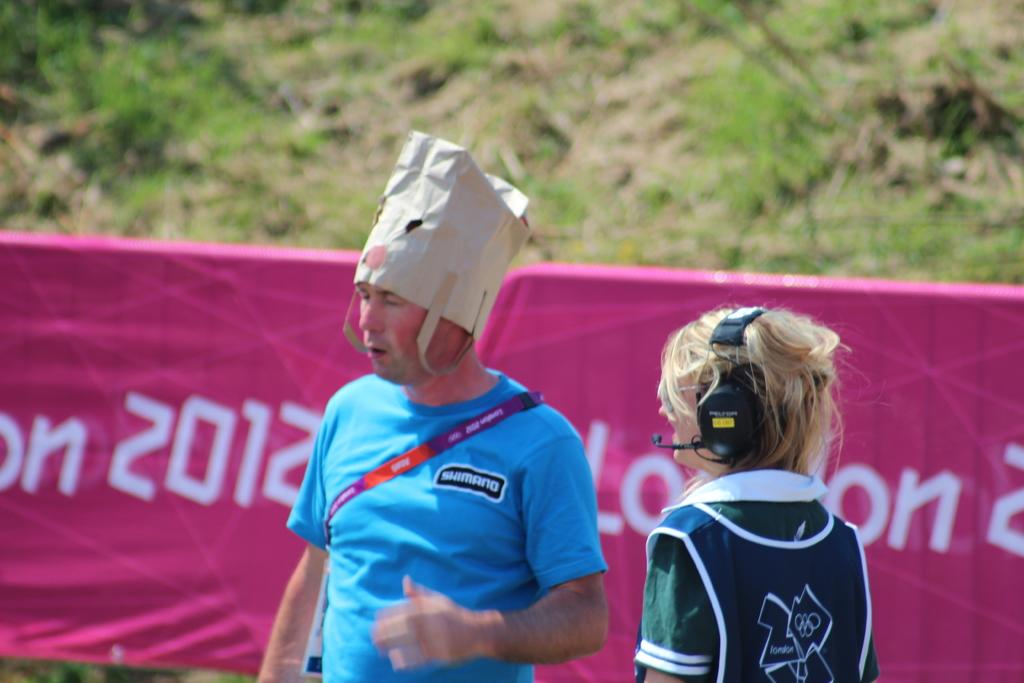<image>
Describe the image concisely. On a banner in the background 2012 is printed in white. 